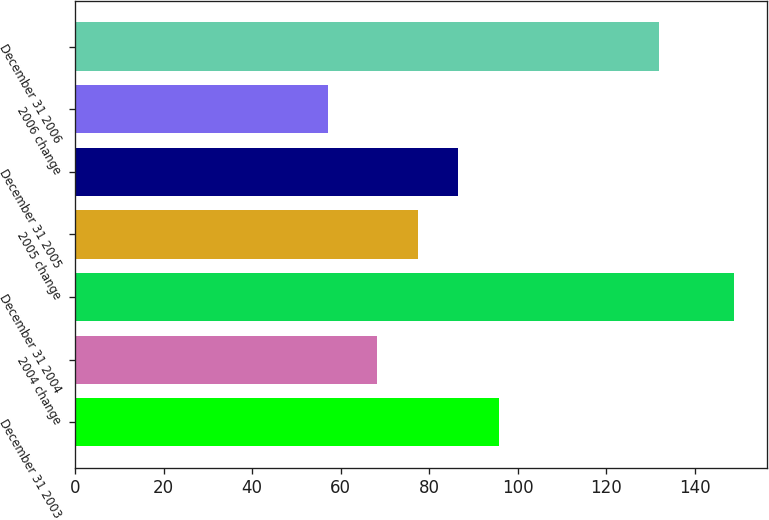<chart> <loc_0><loc_0><loc_500><loc_500><bar_chart><fcel>December 31 2003<fcel>2004 change<fcel>December 31 2004<fcel>2005 change<fcel>December 31 2005<fcel>2006 change<fcel>December 31 2006<nl><fcel>95.71<fcel>68.2<fcel>148.9<fcel>77.37<fcel>86.54<fcel>57.2<fcel>131.8<nl></chart> 